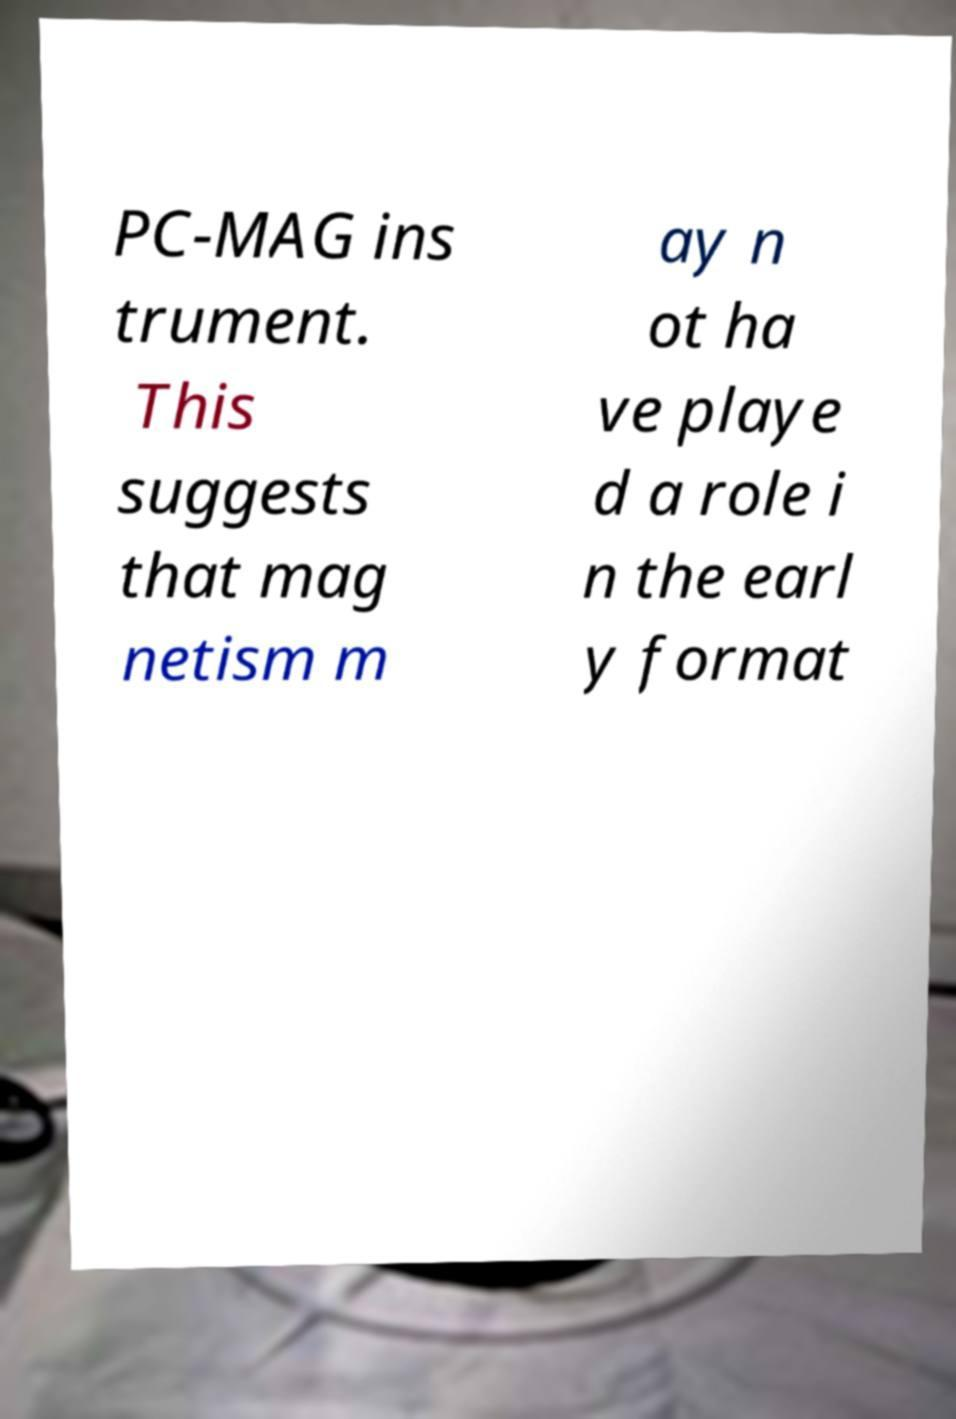Please identify and transcribe the text found in this image. PC-MAG ins trument. This suggests that mag netism m ay n ot ha ve playe d a role i n the earl y format 